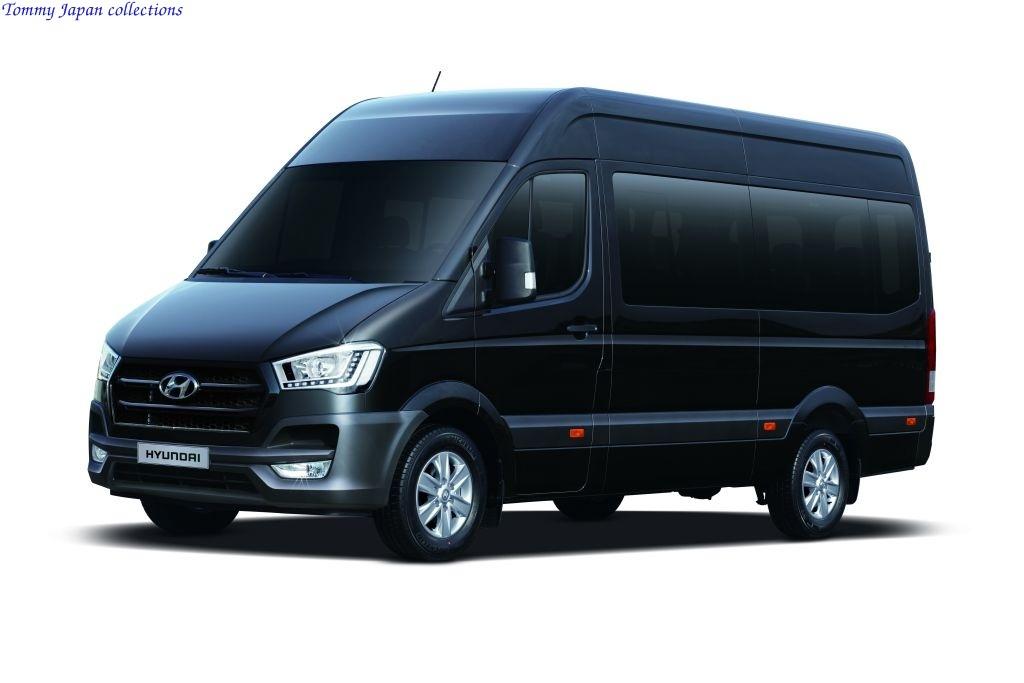Who is the manufacturer of this vehicle?
Your answer should be compact. Hyundai. 